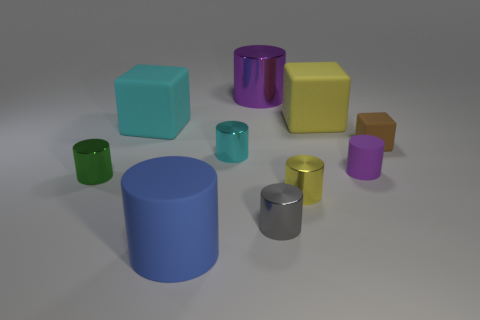What size is the rubber object that is both on the right side of the large yellow rubber cube and behind the cyan shiny object? The rubber object situated to the right of the large yellow cube and behind the cyan object appears to be small in size, particularly when compared to the larger objects in the image. Its compact dimensions suggest it's one of the smallest objects depicted. 